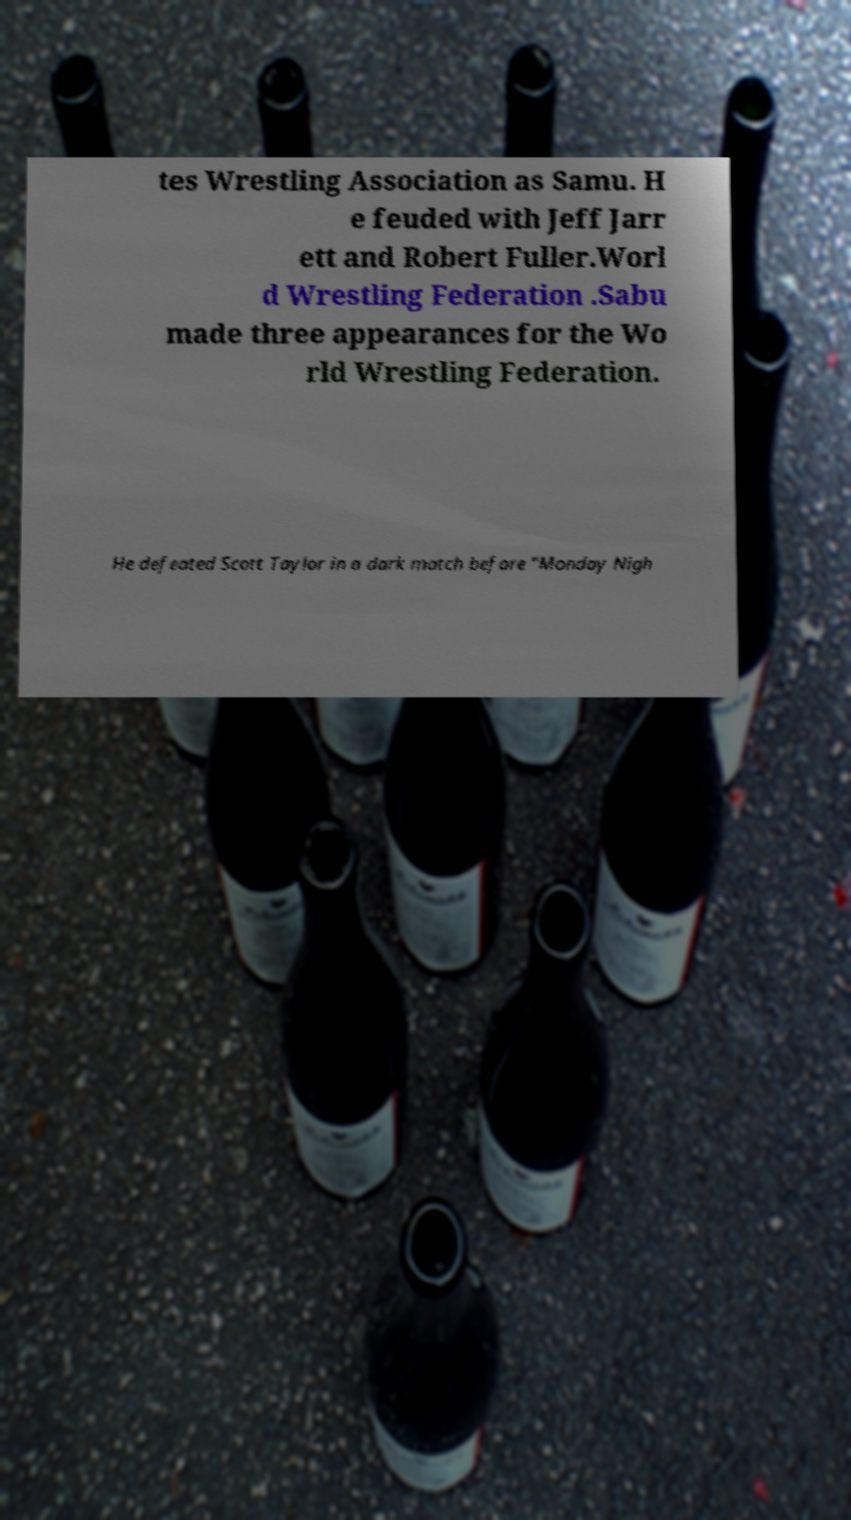Could you extract and type out the text from this image? tes Wrestling Association as Samu. H e feuded with Jeff Jarr ett and Robert Fuller.Worl d Wrestling Federation .Sabu made three appearances for the Wo rld Wrestling Federation. He defeated Scott Taylor in a dark match before "Monday Nigh 